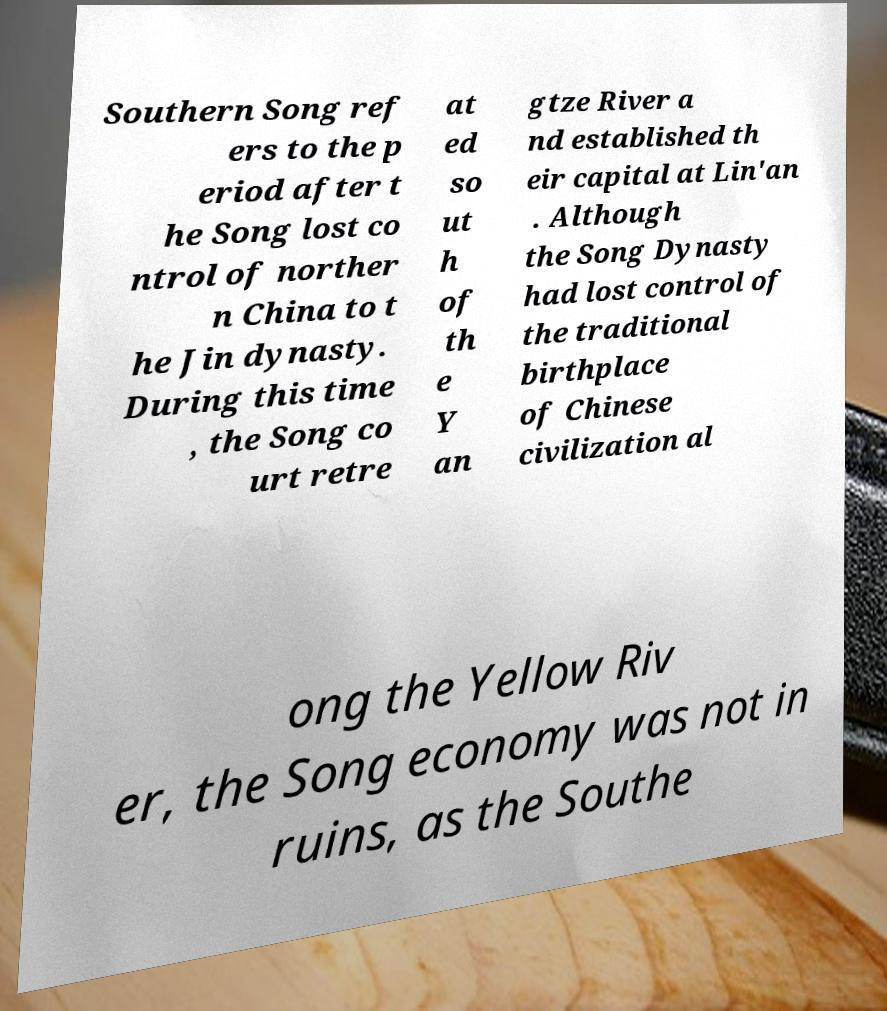What messages or text are displayed in this image? I need them in a readable, typed format. Southern Song ref ers to the p eriod after t he Song lost co ntrol of norther n China to t he Jin dynasty. During this time , the Song co urt retre at ed so ut h of th e Y an gtze River a nd established th eir capital at Lin'an . Although the Song Dynasty had lost control of the traditional birthplace of Chinese civilization al ong the Yellow Riv er, the Song economy was not in ruins, as the Southe 